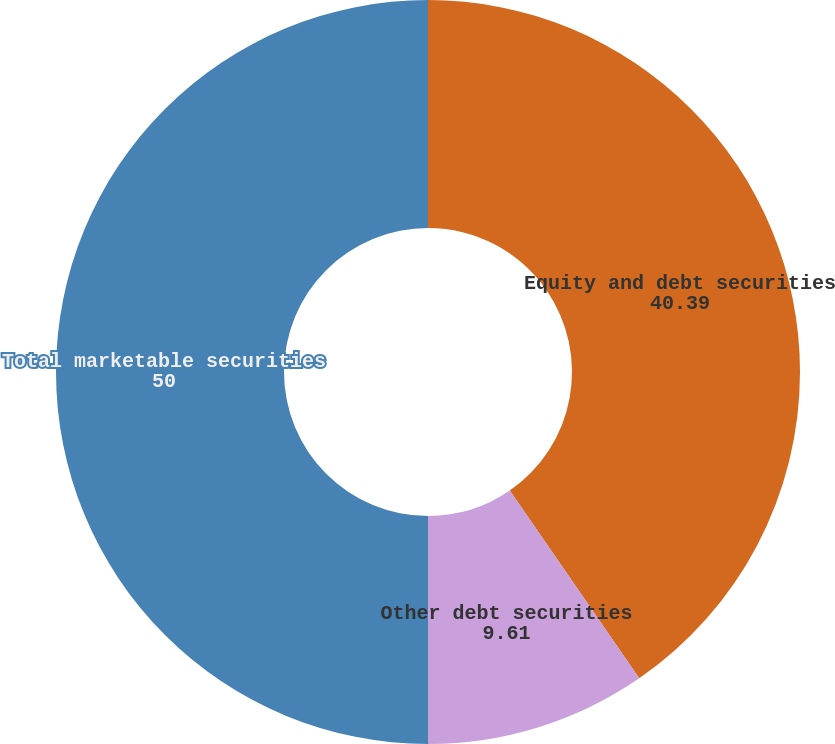<chart> <loc_0><loc_0><loc_500><loc_500><pie_chart><fcel>Equity and debt securities<fcel>Other debt securities<fcel>Total marketable securities<nl><fcel>40.39%<fcel>9.61%<fcel>50.0%<nl></chart> 